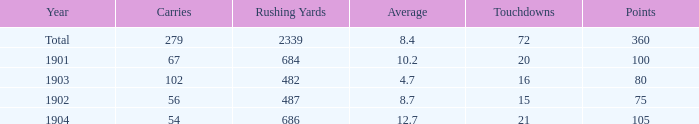What is the sum of carries associated with 80 points and fewer than 16 touchdowns? None. Write the full table. {'header': ['Year', 'Carries', 'Rushing Yards', 'Average', 'Touchdowns', 'Points'], 'rows': [['Total', '279', '2339', '8.4', '72', '360'], ['1901', '67', '684', '10.2', '20', '100'], ['1903', '102', '482', '4.7', '16', '80'], ['1902', '56', '487', '8.7', '15', '75'], ['1904', '54', '686', '12.7', '21', '105']]} 